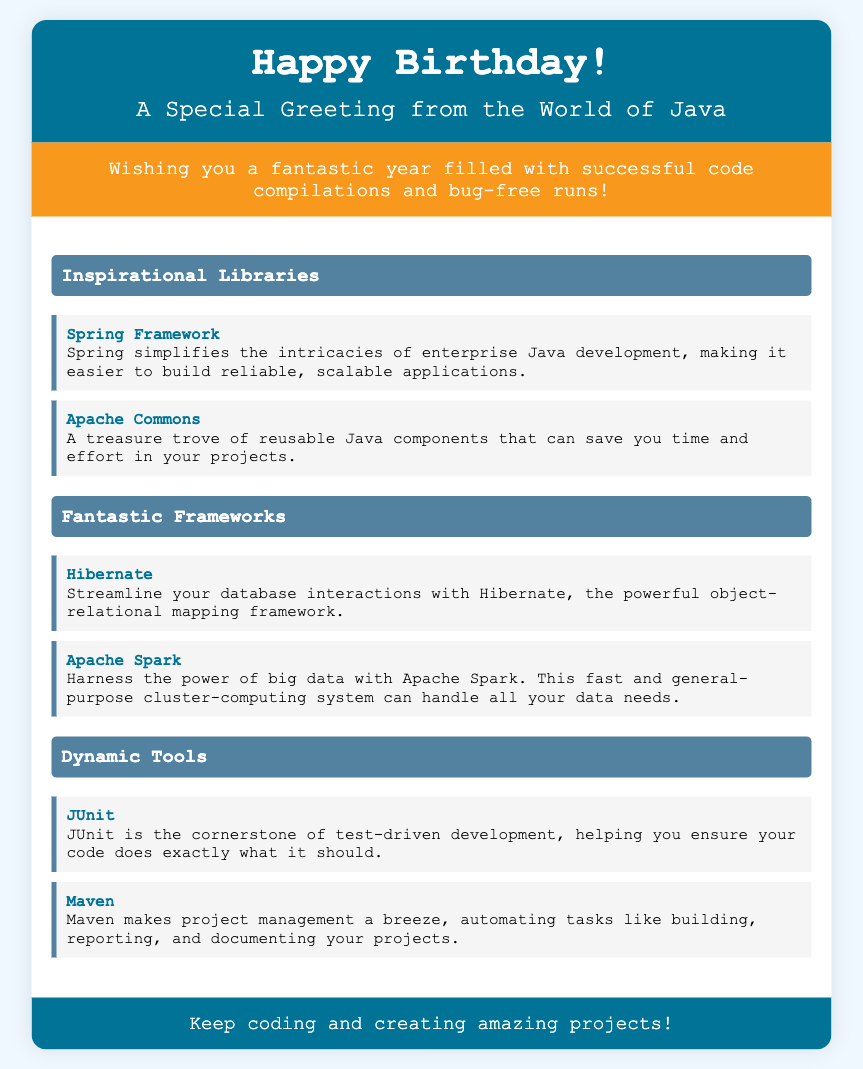What is the header background color? The header background color is specified in the CSS as hex code #007396.
Answer: #007396 What message is included in the card? The message is found in the message section of the card, wishing a fantastic year and mentioning code compilations and bug-free runs.
Answer: Wishing you a fantastic year filled with successful code compilations and bug-free runs! Which library is known for simplifying enterprise Java development? The relevant information is found under the "Inspirational Libraries" section, specifically identifying Spring Framework for this purpose.
Answer: Spring Framework What is the description of JUnit? The description can be found in the "Dynamic Tools" section, detailing JUnit's role in ensuring code functions correctly.
Answer: JUnit is the cornerstone of test-driven development, helping you ensure your code does exactly what it should How many frameworks are listed under the "Fantastic Frameworks" section? The document lists two frameworks in the section, which can be counted directly from the content provided.
Answer: 2 What is the footer message of the card? The footer message is located at the bottom of the card, encouraging continued coding and project creation.
Answer: Keep coding and creating amazing projects! Which tool is known for project management automation? The answer can be found in the "Dynamic Tools" section, identifying Maven's purpose clearly.
Answer: Maven 